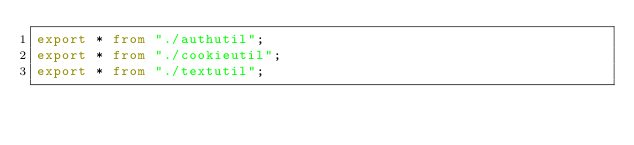<code> <loc_0><loc_0><loc_500><loc_500><_TypeScript_>export * from "./authutil";
export * from "./cookieutil";
export * from "./textutil";
</code> 